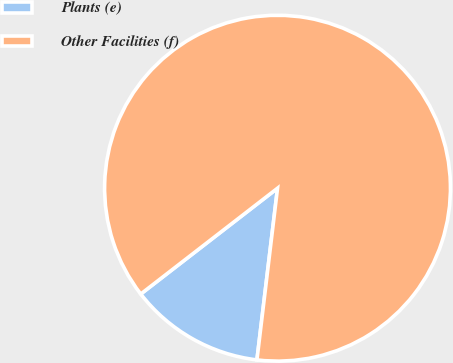<chart> <loc_0><loc_0><loc_500><loc_500><pie_chart><fcel>Plants (e)<fcel>Other Facilities (f)<nl><fcel>12.62%<fcel>87.38%<nl></chart> 